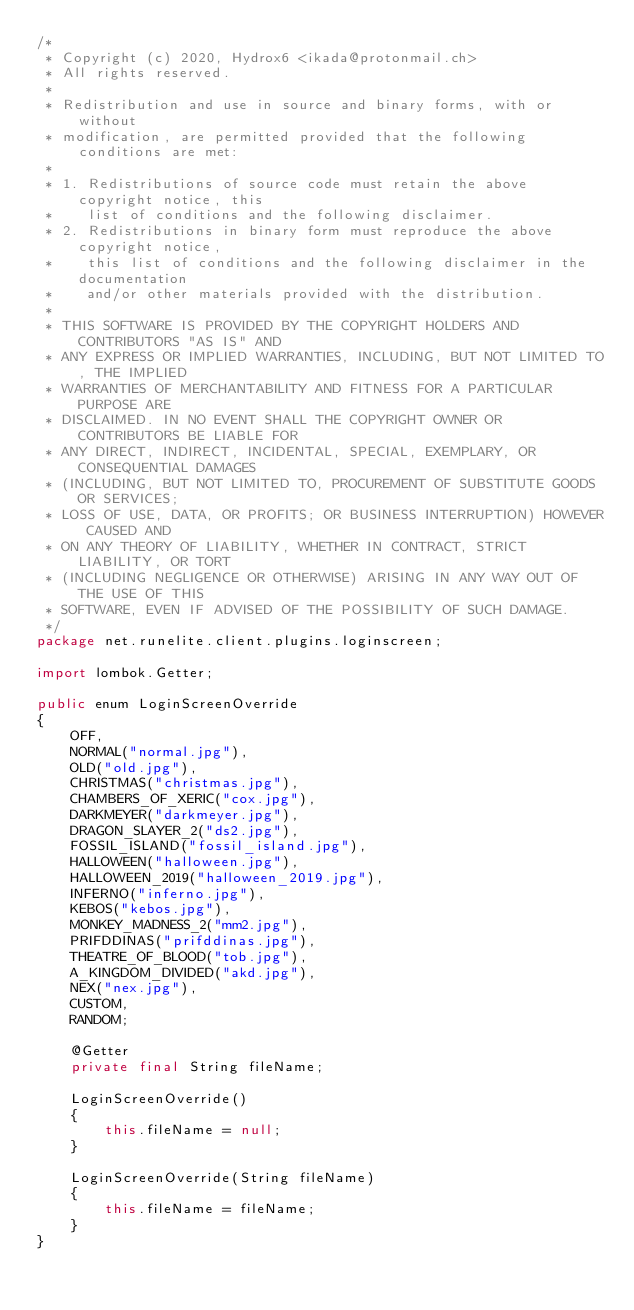<code> <loc_0><loc_0><loc_500><loc_500><_Java_>/*
 * Copyright (c) 2020, Hydrox6 <ikada@protonmail.ch>
 * All rights reserved.
 *
 * Redistribution and use in source and binary forms, with or without
 * modification, are permitted provided that the following conditions are met:
 *
 * 1. Redistributions of source code must retain the above copyright notice, this
 *    list of conditions and the following disclaimer.
 * 2. Redistributions in binary form must reproduce the above copyright notice,
 *    this list of conditions and the following disclaimer in the documentation
 *    and/or other materials provided with the distribution.
 *
 * THIS SOFTWARE IS PROVIDED BY THE COPYRIGHT HOLDERS AND CONTRIBUTORS "AS IS" AND
 * ANY EXPRESS OR IMPLIED WARRANTIES, INCLUDING, BUT NOT LIMITED TO, THE IMPLIED
 * WARRANTIES OF MERCHANTABILITY AND FITNESS FOR A PARTICULAR PURPOSE ARE
 * DISCLAIMED. IN NO EVENT SHALL THE COPYRIGHT OWNER OR CONTRIBUTORS BE LIABLE FOR
 * ANY DIRECT, INDIRECT, INCIDENTAL, SPECIAL, EXEMPLARY, OR CONSEQUENTIAL DAMAGES
 * (INCLUDING, BUT NOT LIMITED TO, PROCUREMENT OF SUBSTITUTE GOODS OR SERVICES;
 * LOSS OF USE, DATA, OR PROFITS; OR BUSINESS INTERRUPTION) HOWEVER CAUSED AND
 * ON ANY THEORY OF LIABILITY, WHETHER IN CONTRACT, STRICT LIABILITY, OR TORT
 * (INCLUDING NEGLIGENCE OR OTHERWISE) ARISING IN ANY WAY OUT OF THE USE OF THIS
 * SOFTWARE, EVEN IF ADVISED OF THE POSSIBILITY OF SUCH DAMAGE.
 */
package net.runelite.client.plugins.loginscreen;

import lombok.Getter;

public enum LoginScreenOverride
{
	OFF,
	NORMAL("normal.jpg"),
	OLD("old.jpg"),
	CHRISTMAS("christmas.jpg"),
	CHAMBERS_OF_XERIC("cox.jpg"),
	DARKMEYER("darkmeyer.jpg"),
	DRAGON_SLAYER_2("ds2.jpg"),
	FOSSIL_ISLAND("fossil_island.jpg"),
	HALLOWEEN("halloween.jpg"),
	HALLOWEEN_2019("halloween_2019.jpg"),
	INFERNO("inferno.jpg"),
	KEBOS("kebos.jpg"),
	MONKEY_MADNESS_2("mm2.jpg"),
	PRIFDDINAS("prifddinas.jpg"),
	THEATRE_OF_BLOOD("tob.jpg"),
	A_KINGDOM_DIVIDED("akd.jpg"),
	NEX("nex.jpg"),
	CUSTOM,
	RANDOM;

	@Getter
	private final String fileName;

	LoginScreenOverride()
	{
		this.fileName = null;
	}

	LoginScreenOverride(String fileName)
	{
		this.fileName = fileName;
	}
}
</code> 